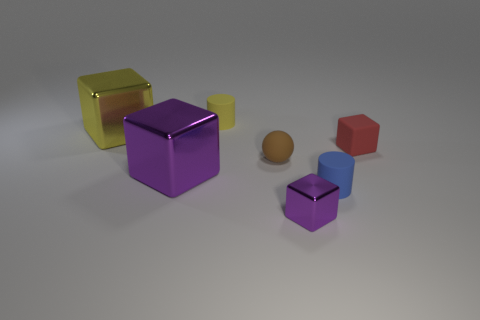Is there anything else that has the same shape as the small brown object?
Offer a terse response. No. There is a large shiny object in front of the red cube; what is its shape?
Your answer should be compact. Cube. Is the shape of the yellow matte object the same as the brown rubber object?
Your response must be concise. No. There is a yellow thing that is the same shape as the tiny red object; what size is it?
Offer a very short reply. Large. Does the cylinder in front of the yellow metal cube have the same size as the red object?
Provide a short and direct response. Yes. What size is the cube that is both to the right of the tiny yellow thing and behind the small purple block?
Give a very brief answer. Small. There is another thing that is the same color as the small metal object; what is its material?
Give a very brief answer. Metal. What number of metal cubes are the same color as the small shiny object?
Make the answer very short. 1. Are there an equal number of rubber cylinders left of the big purple shiny cube and purple rubber objects?
Make the answer very short. Yes. The sphere has what color?
Give a very brief answer. Brown. 